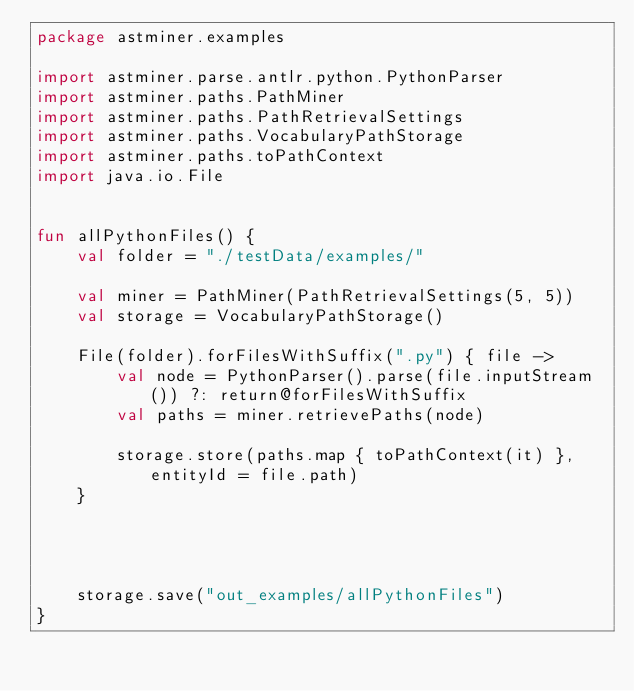<code> <loc_0><loc_0><loc_500><loc_500><_Kotlin_>package astminer.examples

import astminer.parse.antlr.python.PythonParser
import astminer.paths.PathMiner
import astminer.paths.PathRetrievalSettings
import astminer.paths.VocabularyPathStorage
import astminer.paths.toPathContext
import java.io.File


fun allPythonFiles() {
    val folder = "./testData/examples/"

    val miner = PathMiner(PathRetrievalSettings(5, 5))
    val storage = VocabularyPathStorage()

    File(folder).forFilesWithSuffix(".py") { file ->
        val node = PythonParser().parse(file.inputStream()) ?: return@forFilesWithSuffix
        val paths = miner.retrievePaths(node)

        storage.store(paths.map { toPathContext(it) }, entityId = file.path)
    }




    storage.save("out_examples/allPythonFiles")
}</code> 